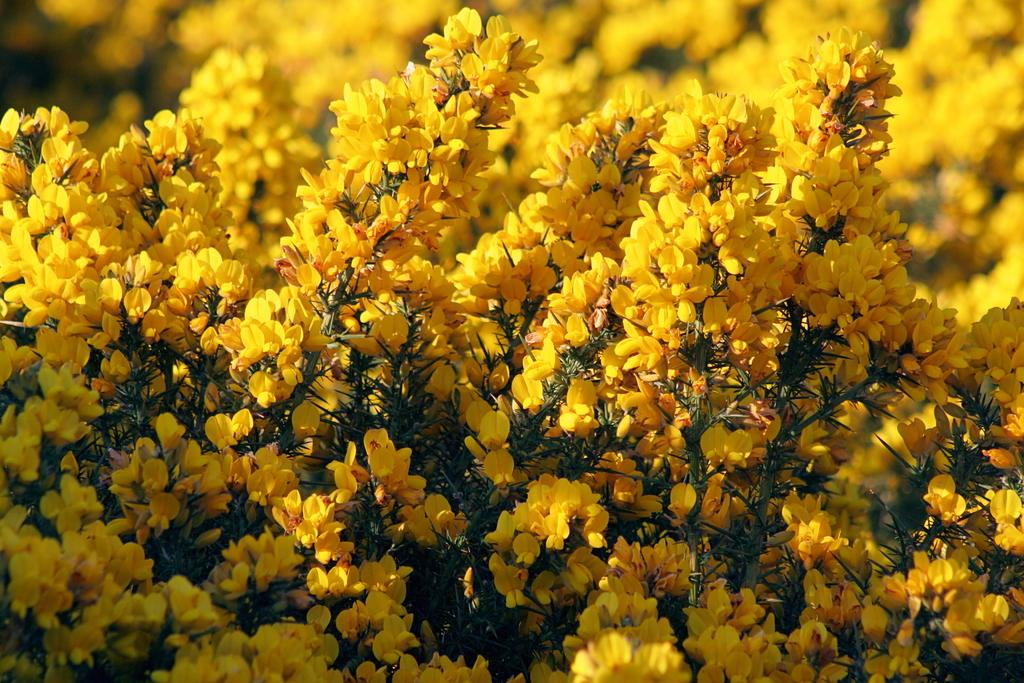What types of living organisms are present in the image? There are many plants in the image. What additional features can be observed on the plants? There are many flowers on the plants in the image. What type of power source can be seen in the image? There is no power source present in the image; it features plants and flowers. Can you tell me how many dinosaurs are visible in the image? There are no dinosaurs present in the image. 